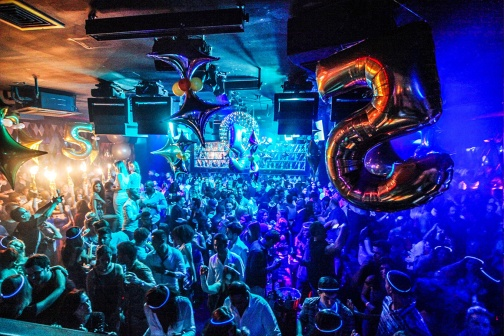Can you describe the atmosphere of the party? The atmosphere at the party is electrifying and full of life. The dim lighting, accentuated by vibrant blue and purple hues, creates a captivating backdrop for the energetic crowd. The music pumping through the nightclub adds to the exuberance, and the sight of people dancing, laughing, and socializing only amplifies the festive spirit. What does the bar look like in this nightclub? The bar in the nightclub is a focal point, well-stocked with a diverse array of bottles and glasses, ready to cater to the revelers' drink requests. The shelves are meticulously arranged, showcasing a variety of spirits and mixers, and the bartenders are busy crafting drinks and engaging with the guests. The bar area is well-lit, contrasting with the dimmer, more atmospheric lighting of the dance floor. Imagine if this was a magical party. How would it look? In a magical twist, this party transforms into an enchanting celebration. The balloons now sparkle with fairy lights, changing colors in sync with the music. The drinks at the bar include glowing, enchanted concoctions that subtly float above the table. The guests are dressed in shimmering, otherworldly outfits, and some even have wings. Dancing on the air currents, ethereal music fills the space with melodies that tickle the soul. A gentle, magical mist hovers just above the floor, enhancing the mystical vibe as beams of light create mesmerizing patterns in this enchanted nightclub. Who's here at the party? The party is attended by a diverse mix of individuals, all united in their desire to celebrate. Friends and colleagues, dressed in their party best, mingle and chat animatedly, while couples share joyful dances. Groups of friends cheer as they enjoy their drinks, and the occasional solitary reveler can be seen swaying to the music, content in the festive atmosphere. What could they be celebrating in a realistic scenario? In a realistic scenario, this lively gathering could be a celebration of a 25th birthday. The abundant balloons and the large '25' shaped foil balloons emphasize the milestone. Alternatively, it could be a 25th wedding anniversary, marking a quarter-century of love and companionship, or a company's 25th anniversary, celebrating years of success and camaraderie within the team. Describe a romantic moment that might occur at this party. As the music slows, the lighting softens, creating an intimate atmosphere within the bustling nightclub. A couple moves to the center of the dance floor, lost in their own world. He takes her hand, pulling her close as they sway gently to the rhythm. Their eyes meet, communicating a depth of emotion that words can't convey. The crowd around them seems to fade away as they share a quiet, tender moment, encapsulated by the magic of the night. 